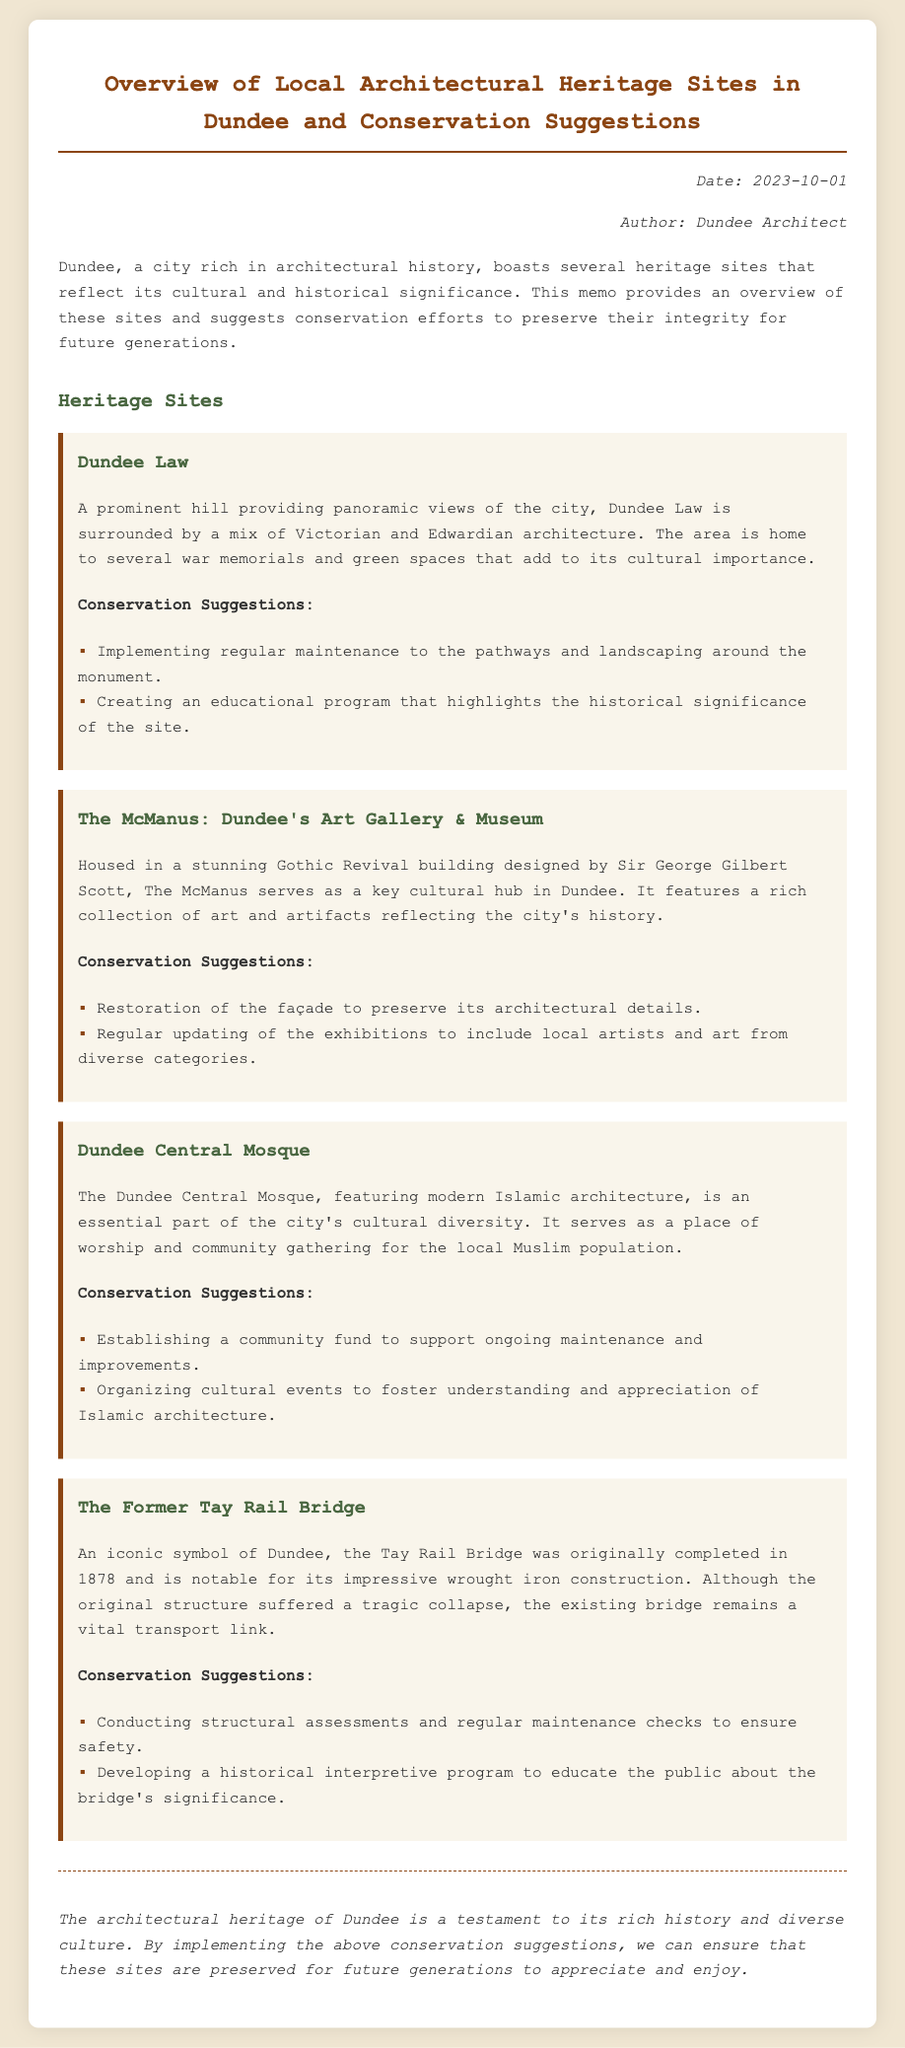What is the date of the memo? The date is mentioned in the meta section of the memo.
Answer: 2023-10-01 Who authored the memo? The author is specified in the meta section of the memo.
Answer: Dundee Architect What is the architectural style of The McManus? The architectural style is described in the section about The McManus.
Answer: Gothic Revival What significant feature does Dundee Law have? The significant feature is mentioned in the description of Dundee Law.
Answer: Panoramic views How many conservation suggestions are provided for the Dundee Central Mosque? The number of suggestions is counted in the conservation suggestions section.
Answer: Two What tragic event is associated with the Tay Rail Bridge? The event is referenced in the description of The Former Tay Rail Bridge.
Answer: Collapse What type of program is suggested for Dundee Law? The type of program is described in the conservation suggestions for Dundee Law.
Answer: Educational program What is the main mission of The McManus? The main mission is implied in its description as a cultural hub.
Answer: Key cultural hub What kind of fund is suggested for the Dundee Central Mosque? The type of fund is mentioned in the conservation suggestions.
Answer: Community fund 